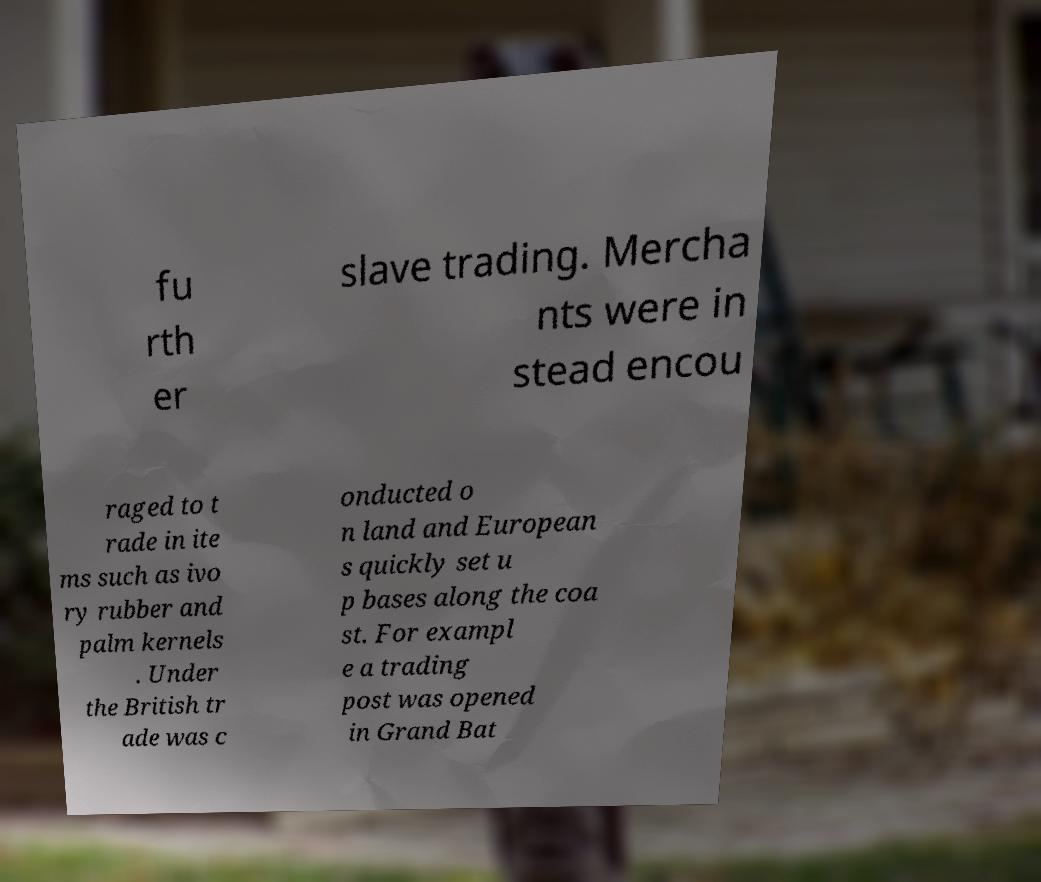Could you assist in decoding the text presented in this image and type it out clearly? fu rth er slave trading. Mercha nts were in stead encou raged to t rade in ite ms such as ivo ry rubber and palm kernels . Under the British tr ade was c onducted o n land and European s quickly set u p bases along the coa st. For exampl e a trading post was opened in Grand Bat 